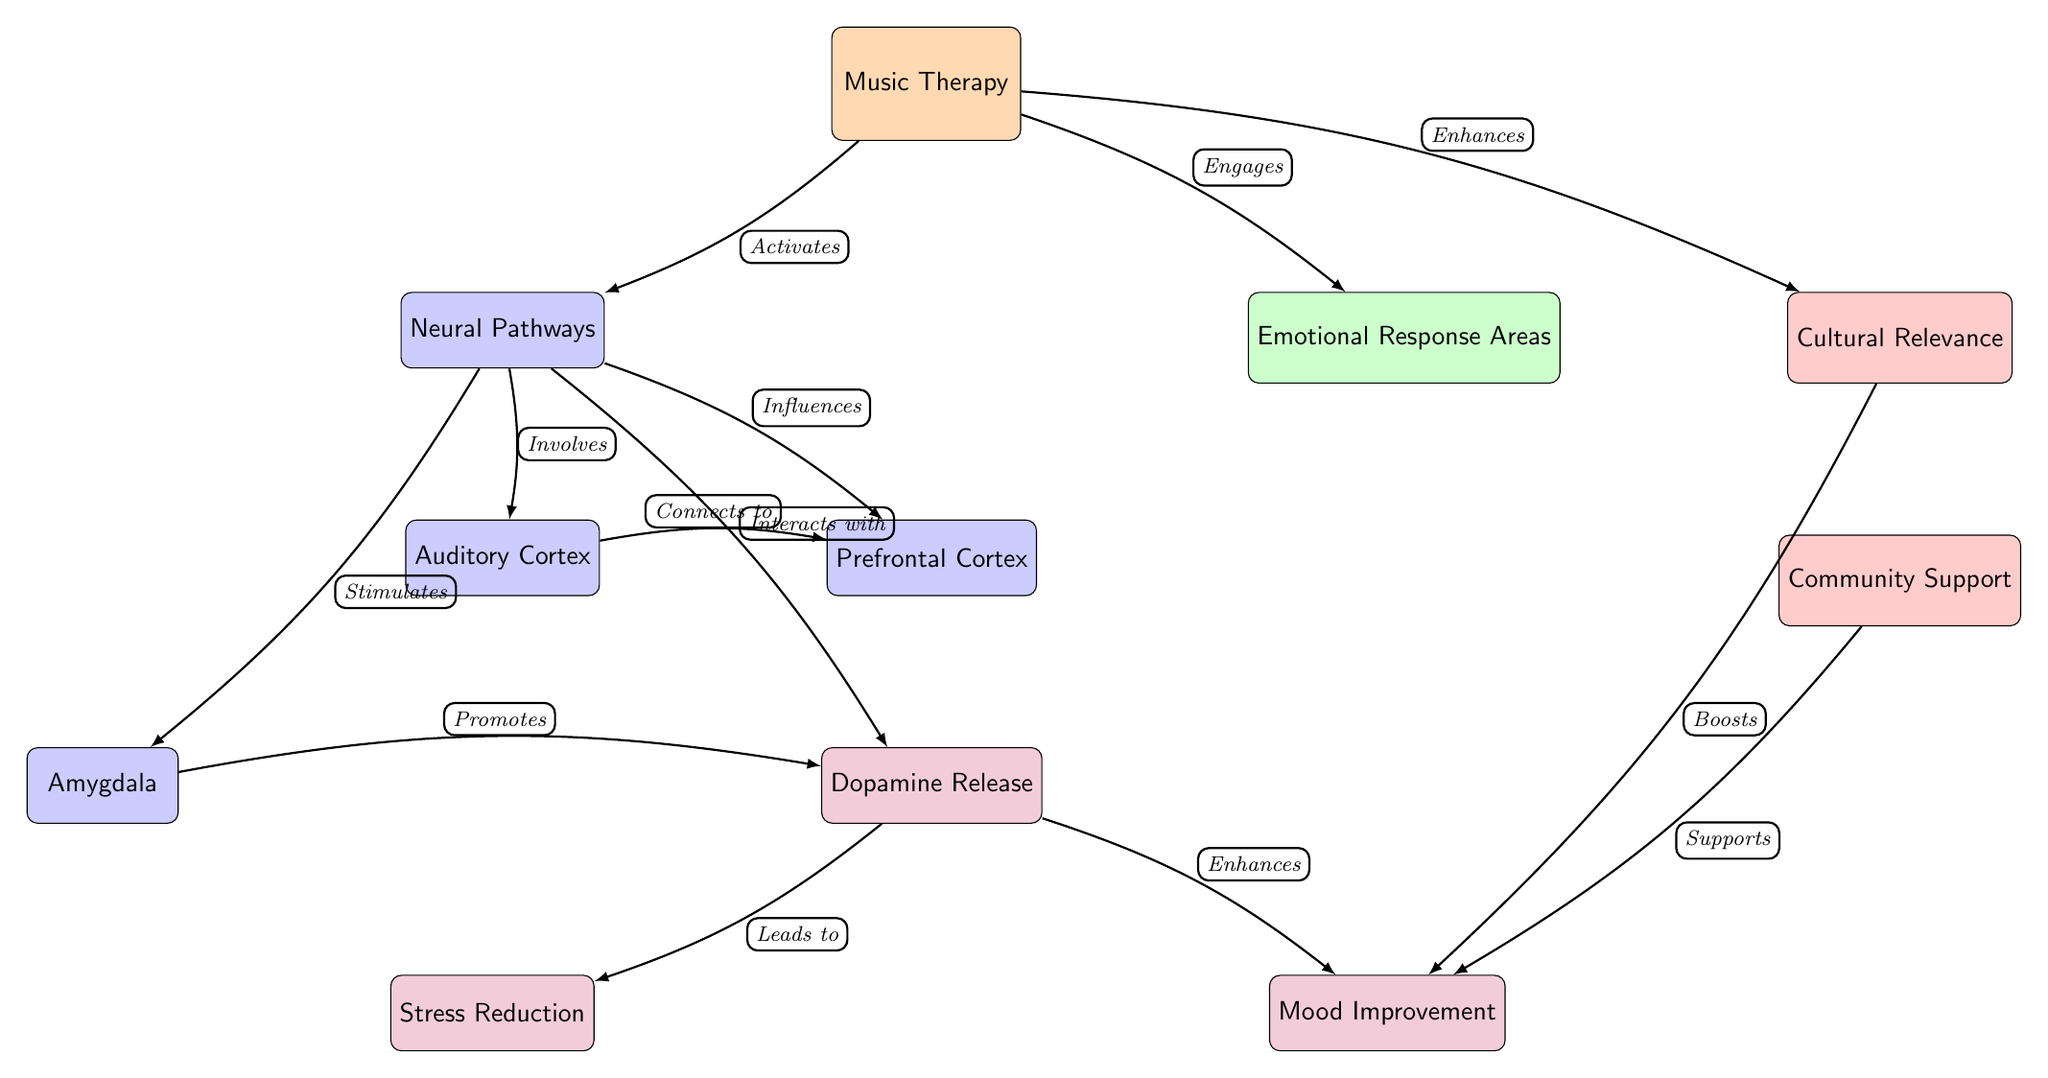What is the main component represented at the top of the diagram? The node at the top of the diagram represents "Music Therapy," which is labeled as the starting point or primary focus of the relationships illustrated in the diagram.
Answer: Music Therapy How many sub-components are connected to the "Neural Pathways" node? The "Neural Pathways" node is directly connected to four sub-nodes: "Auditory Cortex," "Prefrontal Cortex," "Amygdala," and "Hippocampus." Therefore, there are four sub-components connected to it.
Answer: 4 What emotional response area is indicated to be influenced by the "Amygdala"? The diagram shows that the "Amygdala" contributes to the "Dopamine Release" node. It influences emotional responses as related to dopamine, which is an important neurotransmitter associated with pleasure and reward.
Answer: Dopamine Release Which node does the "Cultural Relevance" area directly enhance? The "Cultural Relevance" node is shown to enhance the "Mood Improvement" effect, illustrating the positive influence of cultural aspects on emotional well-being.
Answer: Mood Improvement What type of relationship is shown between "Music Therapy" and "Emotional Response Areas"? The relationship illustrated between "Music Therapy" and "Emotional Response Areas" is labeled as "Engages," highlighting how music therapy actively involves emotional processing and response.
Answer: Engages What is the final effect of "Dopamine Release" according to the diagram? The diagram indicates that "Dopamine Release" leads to two outcomes: "Stress Reduction" and "Mood Improvement." These effects underscore the significance of dopamine in enhancing mental health.
Answer: Stress Reduction, Mood Improvement How do "Community Support" and "Cultural Relevance" relate to the overall mood improvement? The diagram shows that both "Community Support" and "Cultural Relevance" boost mood, indicating a direct relationship between community engagement, cultural identity, and positive emotional outcomes.
Answer: Boosts Mood What is the connection direction between the "Auditory Cortex" and the "Prefrontal Cortex"? The connection is illustrated as a bi-directional flow, where the "Auditory Cortex" is shown to connect to and influence the "Prefrontal Cortex," indicating that processing music activates regions involved in decision-making and emotion regulation.
Answer: Connects to What effect does "Music Therapy" have on the overall mood according to the diagram? The diagram depicts that "Music Therapy" enhances the cultural relevance and therefore indirectly influences mood. This highlights how therapeutic music experiences are significant for uplifting spirits in the community.
Answer: Enhances Mood 